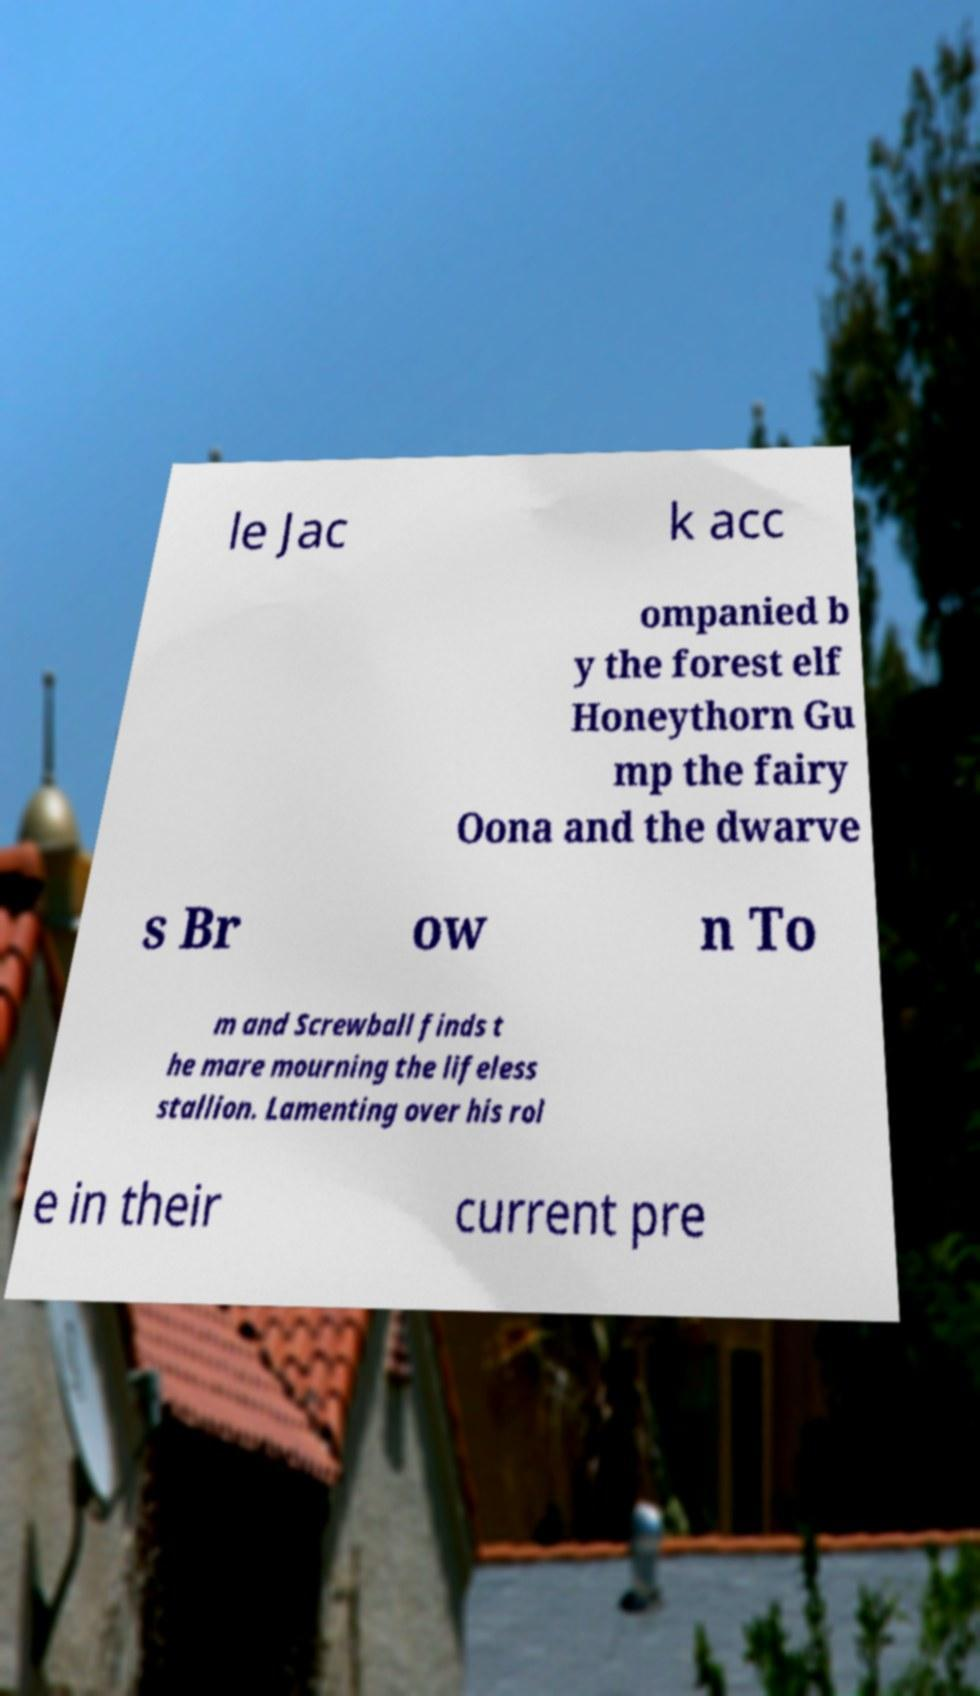Could you assist in decoding the text presented in this image and type it out clearly? le Jac k acc ompanied b y the forest elf Honeythorn Gu mp the fairy Oona and the dwarve s Br ow n To m and Screwball finds t he mare mourning the lifeless stallion. Lamenting over his rol e in their current pre 